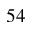<formula> <loc_0><loc_0><loc_500><loc_500>5 4</formula> 